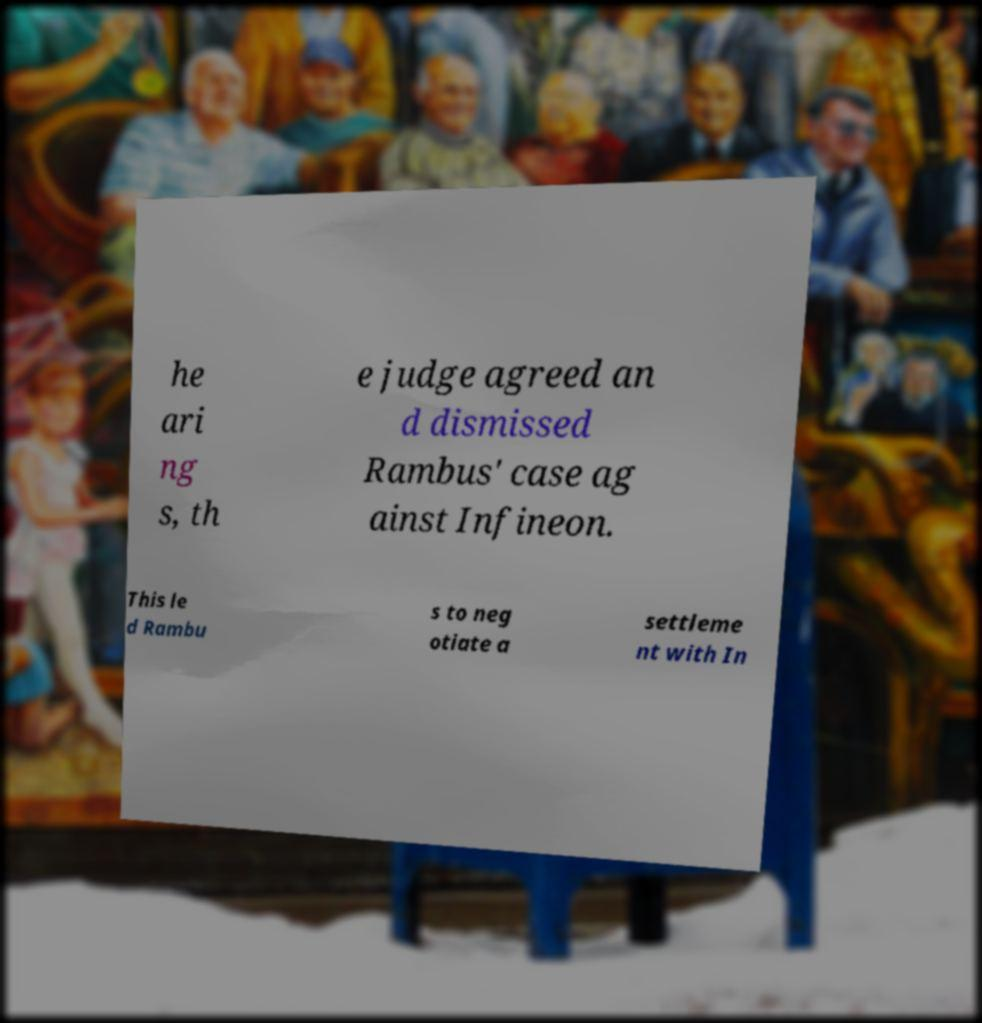Please identify and transcribe the text found in this image. he ari ng s, th e judge agreed an d dismissed Rambus' case ag ainst Infineon. This le d Rambu s to neg otiate a settleme nt with In 